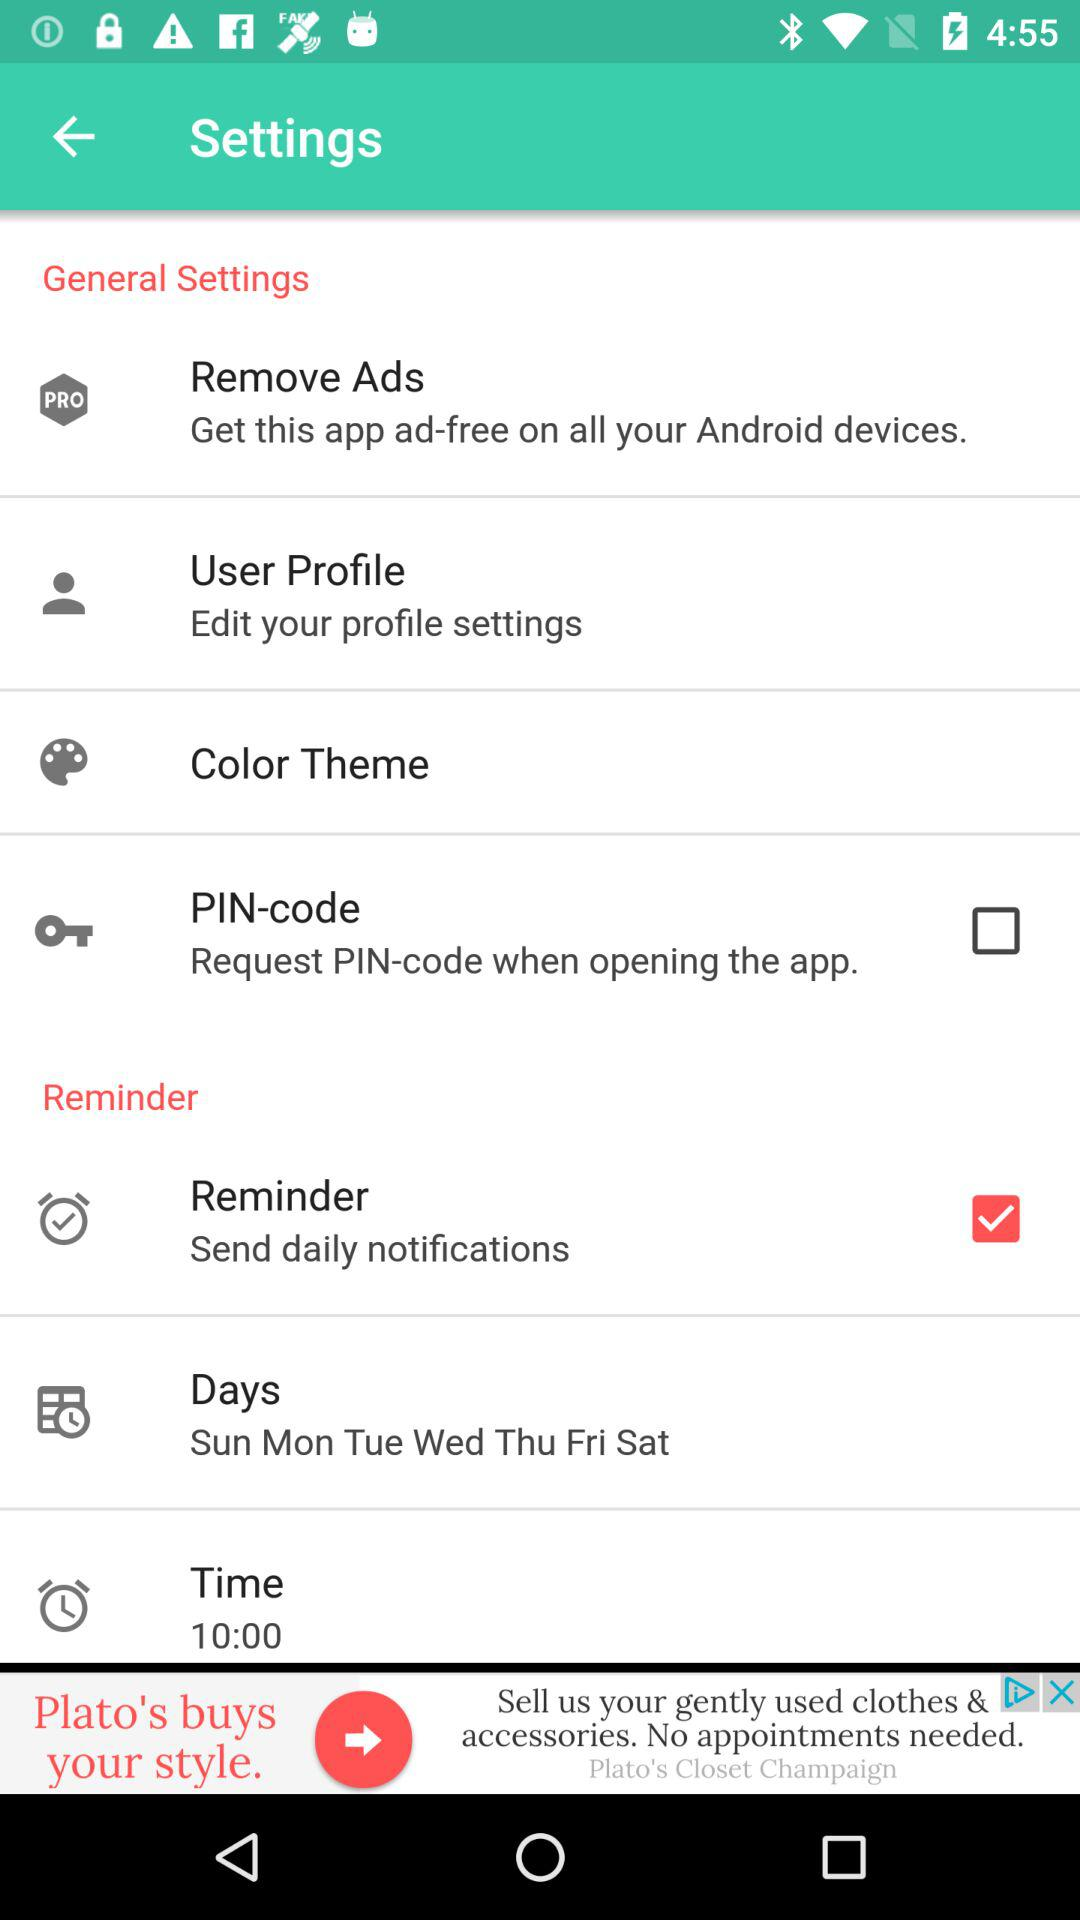What is the set time for the reminder? The set time for the reminder is 10:00. 